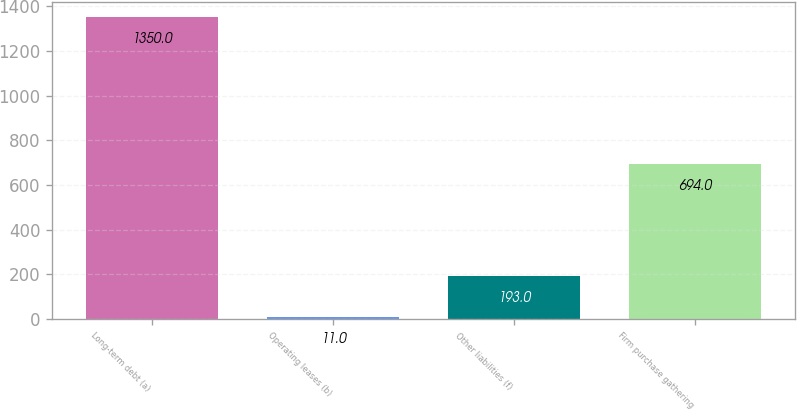Convert chart. <chart><loc_0><loc_0><loc_500><loc_500><bar_chart><fcel>Long-term debt (a)<fcel>Operating leases (b)<fcel>Other liabilities (f)<fcel>Firm purchase gathering<nl><fcel>1350<fcel>11<fcel>193<fcel>694<nl></chart> 